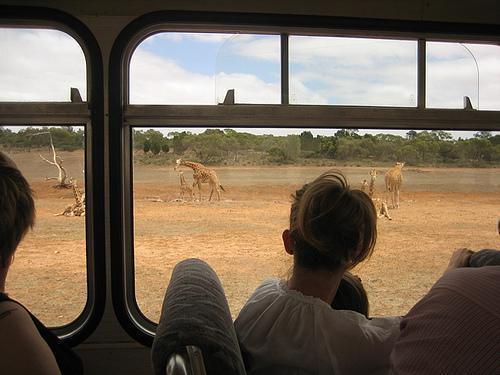How many people are there?
Give a very brief answer. 3. 